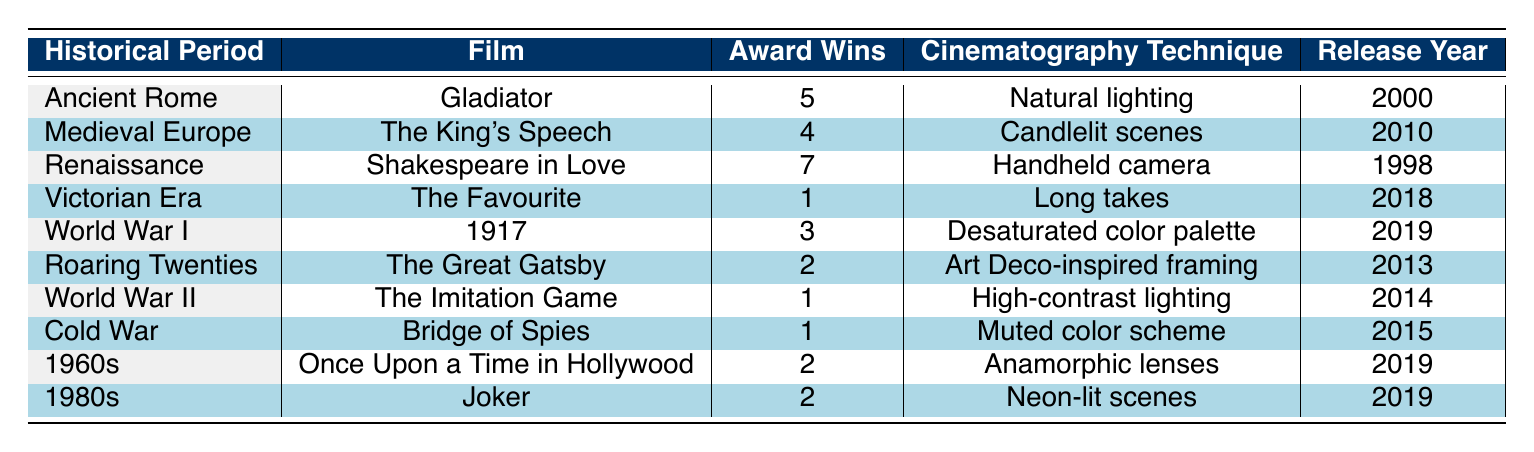What is the film set in Ancient Rome? The table lists "Gladiator" as the film associated with the historical period of Ancient Rome.
Answer: Gladiator Which historical period had the most award wins? By reviewing the "Award Wins" column, "Shakespeare in Love" from the Renaissance period has the highest number of wins, totaling 7.
Answer: Renaissance How many total award wins are there from films set in the 1960s and 1980s? Summing the award wins for films "Once Upon a Time in Hollywood" (2 wins) and "Joker" (2 wins) gives a total of 4 award wins.
Answer: 4 Did the film "The Favourite" win more awards than "The Imitation Game"? "The Favourite" won 1 award while "The Imitation Game" also won 1 award. Therefore, the statement is false as both films won the same number of awards.
Answer: No What is the release year of the film with the most award wins? The film "Shakespeare in Love," which has the highest award wins (7), was released in 1998.
Answer: 1998 Which cinematography technique is used in "1917"? The table indicates that "1917" employs the "Desaturated color palette" as its cinematography technique.
Answer: Desaturated color palette Is there any film from the World War II period that won more than 1 award? "The Imitation Game," which is from the World War II period, only won 1 award, so there is no film from that period that won more than 1 award.
Answer: No What are two films released in 2019 and their award counts? The films released in 2019 are "1917" with 3 awards and "Once Upon a Time in Hollywood" with 2 awards.
Answer: 1917 (3), Once Upon a Time in Hollywood (2) Which is the only film that won just 1 award? Three films, "The Favourite," "The Imitation Game," and "Bridge of Spies," each won just 1 award.
Answer: The Favourite, The Imitation Game, Bridge of Spies What is the difference in award wins between "Gladiator" and "The King's Speech"? "Gladiator" has 5 award wins while "The King's Speech" has 4. Thus, the difference in award wins is 5 - 4 = 1.
Answer: 1 